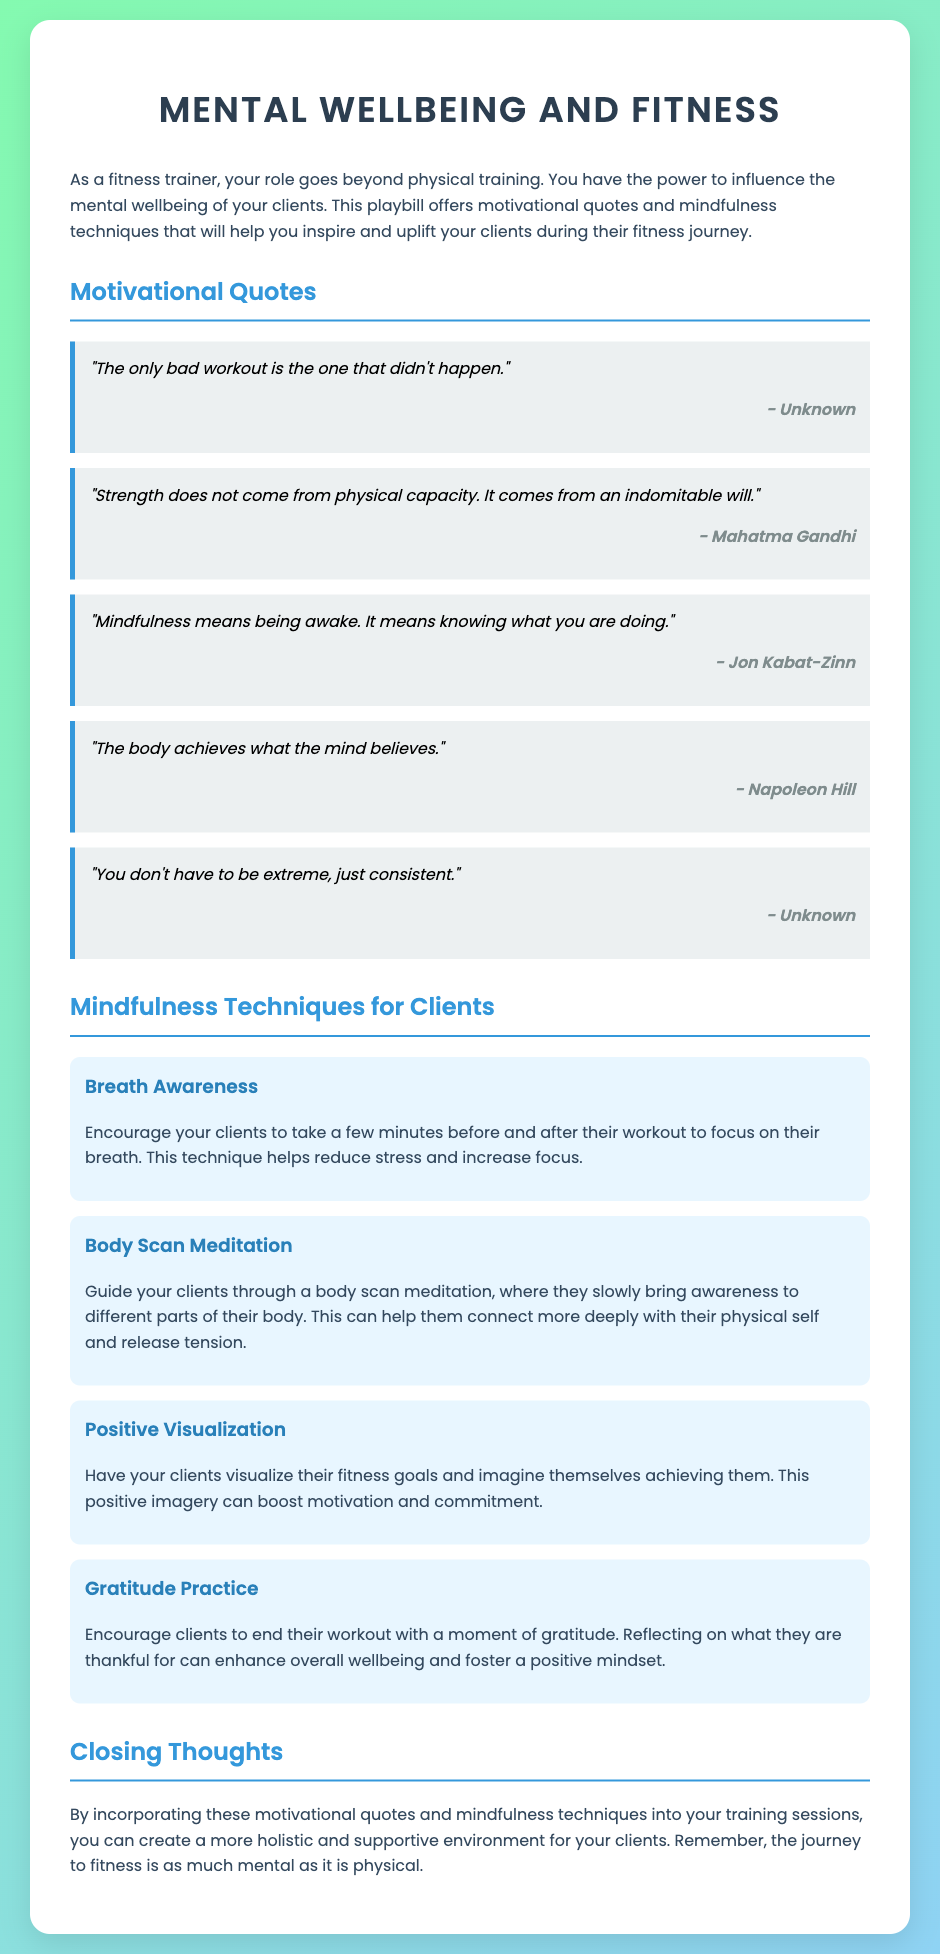what is the title of the playbill? The title is prominently displayed at the top of the document, which is "Mental Wellbeing and Fitness."
Answer: Mental Wellbeing and Fitness who is credited with the quote, "Strength does not come from physical capacity. It comes from an indomitable will."? This quote is attributed to Mahatma Gandhi in the motivational quotes section.
Answer: Mahatma Gandhi how many mindfulness techniques are listed in the document? The document contains multiple techniques listed under the "Mindfulness Techniques for Clients" section.
Answer: Four what quote emphasizes consistency over extremity in workouts? The specific quote that emphasizes this idea is included in the motivational quotes section.
Answer: "You don't have to be extreme, just consistent." what mindfulness technique encourages reflection on gratitude? This technique is described towards the end of the mindfulness techniques section and promotes a positive reflection.
Answer: Gratitude Practice what is one benefit of the Breath Awareness technique? The document mentions that this technique helps reduce stress and increase focus.
Answer: Reduce stress and increase focus which author is associated with the quote, "The body achieves what the mind believes."? This motivational quote is attributed to Napoleon Hill within the document.
Answer: Napoleon Hill what is the main purpose of incorporating quotes and techniques in training sessions? The document indicates that these elements aim to create a supportive environment for clients.
Answer: Supportive environment 